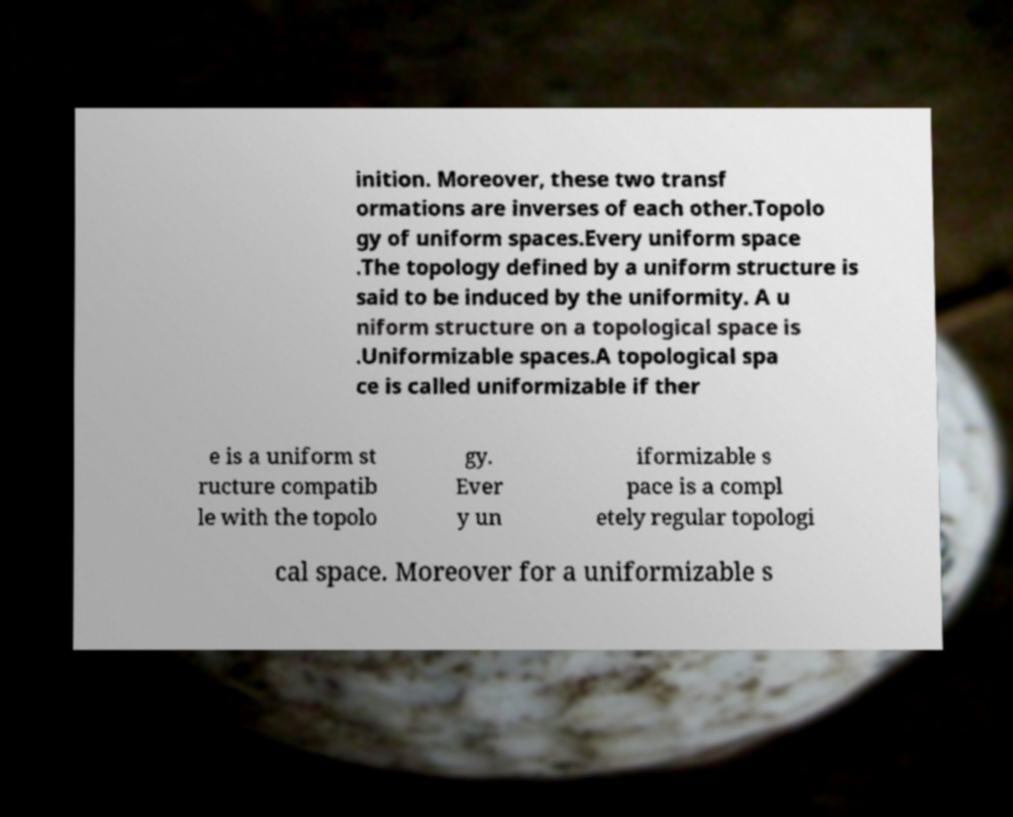Please identify and transcribe the text found in this image. inition. Moreover, these two transf ormations are inverses of each other.Topolo gy of uniform spaces.Every uniform space .The topology defined by a uniform structure is said to be induced by the uniformity. A u niform structure on a topological space is .Uniformizable spaces.A topological spa ce is called uniformizable if ther e is a uniform st ructure compatib le with the topolo gy. Ever y un iformizable s pace is a compl etely regular topologi cal space. Moreover for a uniformizable s 